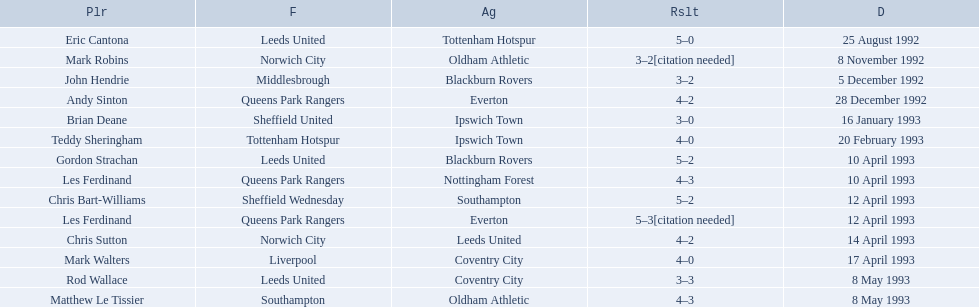Who are the players in 1992-93 fa premier league? Eric Cantona, Mark Robins, John Hendrie, Andy Sinton, Brian Deane, Teddy Sheringham, Gordon Strachan, Les Ferdinand, Chris Bart-Williams, Les Ferdinand, Chris Sutton, Mark Walters, Rod Wallace, Matthew Le Tissier. Parse the full table. {'header': ['Plr', 'F', 'Ag', 'Rslt', 'D'], 'rows': [['Eric Cantona', 'Leeds United', 'Tottenham Hotspur', '5–0', '25 August 1992'], ['Mark Robins', 'Norwich City', 'Oldham Athletic', '3–2[citation needed]', '8 November 1992'], ['John Hendrie', 'Middlesbrough', 'Blackburn Rovers', '3–2', '5 December 1992'], ['Andy Sinton', 'Queens Park Rangers', 'Everton', '4–2', '28 December 1992'], ['Brian Deane', 'Sheffield United', 'Ipswich Town', '3–0', '16 January 1993'], ['Teddy Sheringham', 'Tottenham Hotspur', 'Ipswich Town', '4–0', '20 February 1993'], ['Gordon Strachan', 'Leeds United', 'Blackburn Rovers', '5–2', '10 April 1993'], ['Les Ferdinand', 'Queens Park Rangers', 'Nottingham Forest', '4–3', '10 April 1993'], ['Chris Bart-Williams', 'Sheffield Wednesday', 'Southampton', '5–2', '12 April 1993'], ['Les Ferdinand', 'Queens Park Rangers', 'Everton', '5–3[citation needed]', '12 April 1993'], ['Chris Sutton', 'Norwich City', 'Leeds United', '4–2', '14 April 1993'], ['Mark Walters', 'Liverpool', 'Coventry City', '4–0', '17 April 1993'], ['Rod Wallace', 'Leeds United', 'Coventry City', '3–3', '8 May 1993'], ['Matthew Le Tissier', 'Southampton', 'Oldham Athletic', '4–3', '8 May 1993']]} What is mark robins' result? 3–2[citation needed]. Which player has the same result? John Hendrie. 